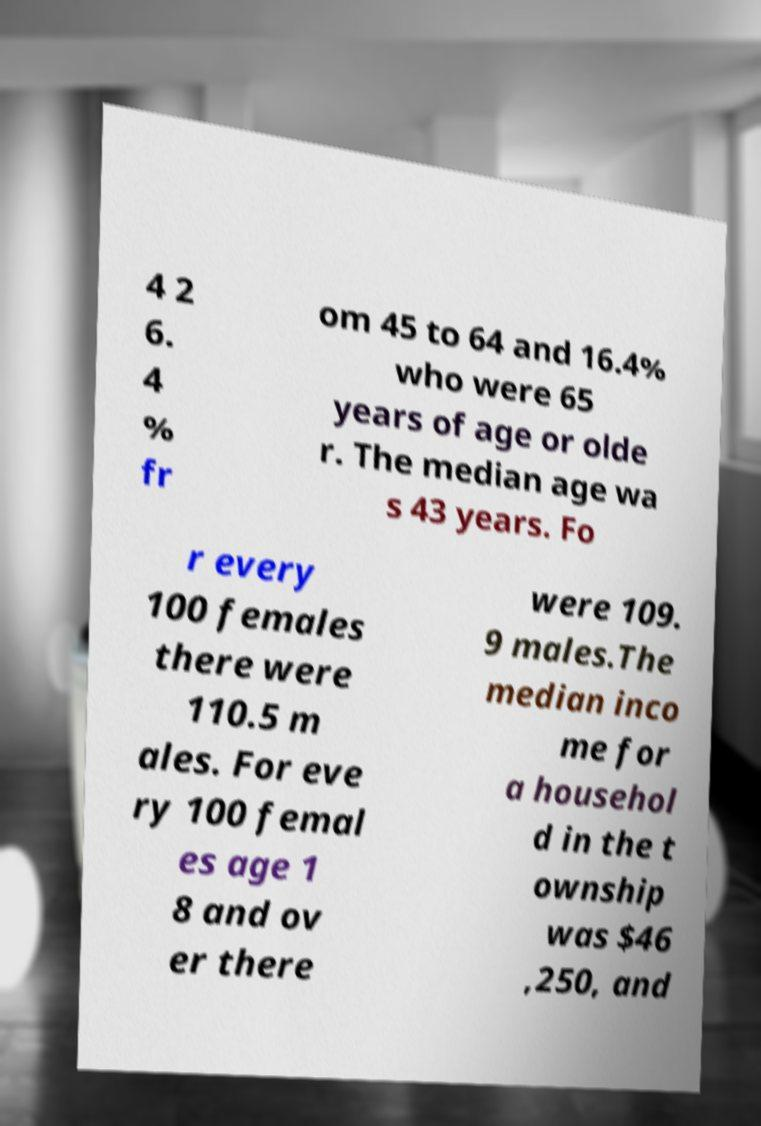There's text embedded in this image that I need extracted. Can you transcribe it verbatim? 4 2 6. 4 % fr om 45 to 64 and 16.4% who were 65 years of age or olde r. The median age wa s 43 years. Fo r every 100 females there were 110.5 m ales. For eve ry 100 femal es age 1 8 and ov er there were 109. 9 males.The median inco me for a househol d in the t ownship was $46 ,250, and 